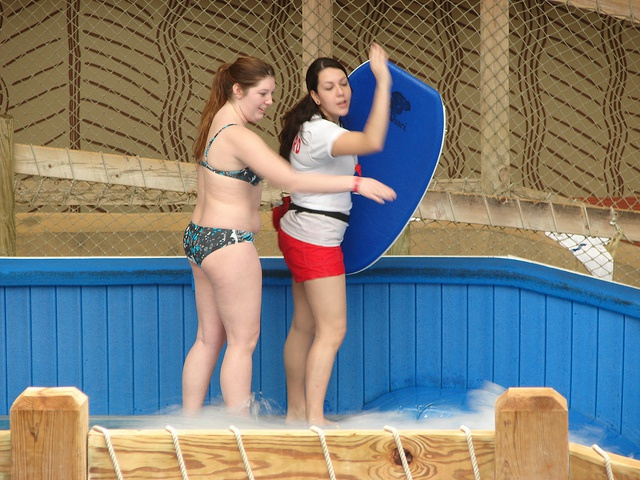Describe the objects in this image and their specific colors. I can see people in olive, tan, and darkgray tones, people in olive, tan, lightgray, and gray tones, and surfboard in olive, blue, darkblue, navy, and lightgray tones in this image. 